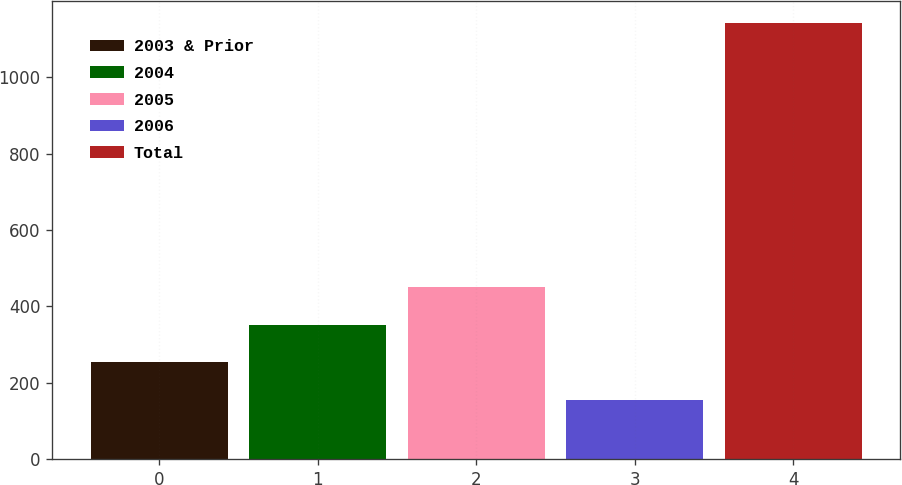Convert chart to OTSL. <chart><loc_0><loc_0><loc_500><loc_500><bar_chart><fcel>2003 & Prior<fcel>2004<fcel>2005<fcel>2006<fcel>Total<nl><fcel>253.7<fcel>352.4<fcel>451.1<fcel>155<fcel>1142<nl></chart> 